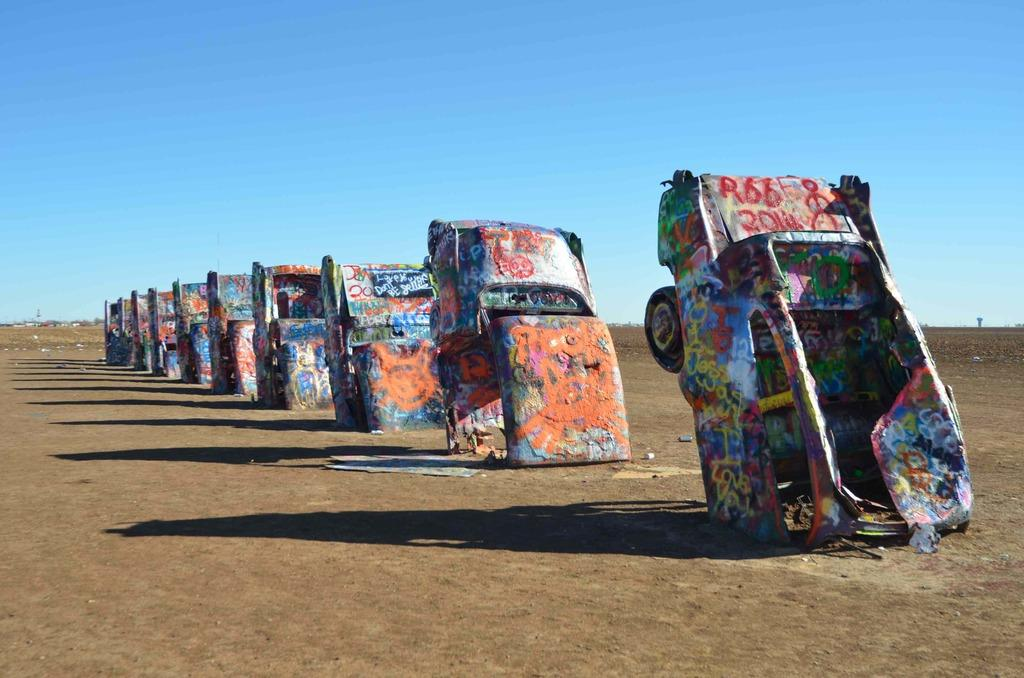What is the main subject in the center of the image? There are trucks in the center of the image. What can be seen at the top of the image? The sky is visible at the top of the image. What is present at the bottom of the image? The ground is present at the bottom of the image. How many geese are flying in the sky in the image? There are no geese present in the image; only trucks, sky, and ground are visible. What type of machine is being used by the geese in the image? There are no geese or machines present in the image. 